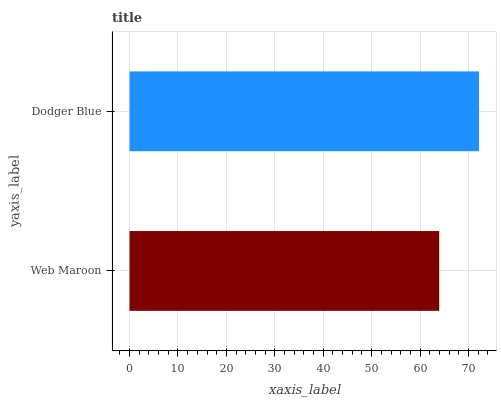Is Web Maroon the minimum?
Answer yes or no. Yes. Is Dodger Blue the maximum?
Answer yes or no. Yes. Is Dodger Blue the minimum?
Answer yes or no. No. Is Dodger Blue greater than Web Maroon?
Answer yes or no. Yes. Is Web Maroon less than Dodger Blue?
Answer yes or no. Yes. Is Web Maroon greater than Dodger Blue?
Answer yes or no. No. Is Dodger Blue less than Web Maroon?
Answer yes or no. No. Is Dodger Blue the high median?
Answer yes or no. Yes. Is Web Maroon the low median?
Answer yes or no. Yes. Is Web Maroon the high median?
Answer yes or no. No. Is Dodger Blue the low median?
Answer yes or no. No. 